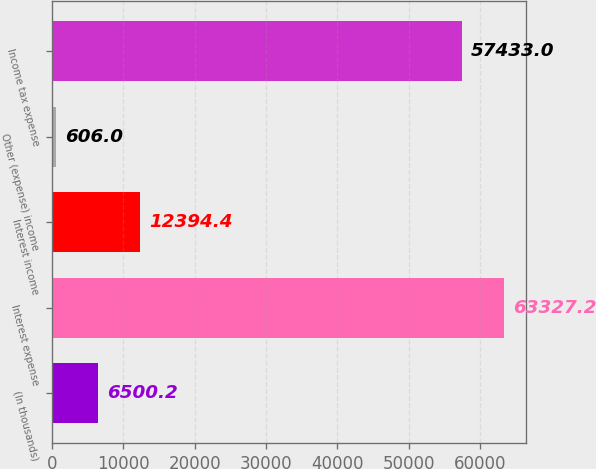Convert chart to OTSL. <chart><loc_0><loc_0><loc_500><loc_500><bar_chart><fcel>(In thousands)<fcel>Interest expense<fcel>Interest income<fcel>Other (expense) income<fcel>Income tax expense<nl><fcel>6500.2<fcel>63327.2<fcel>12394.4<fcel>606<fcel>57433<nl></chart> 